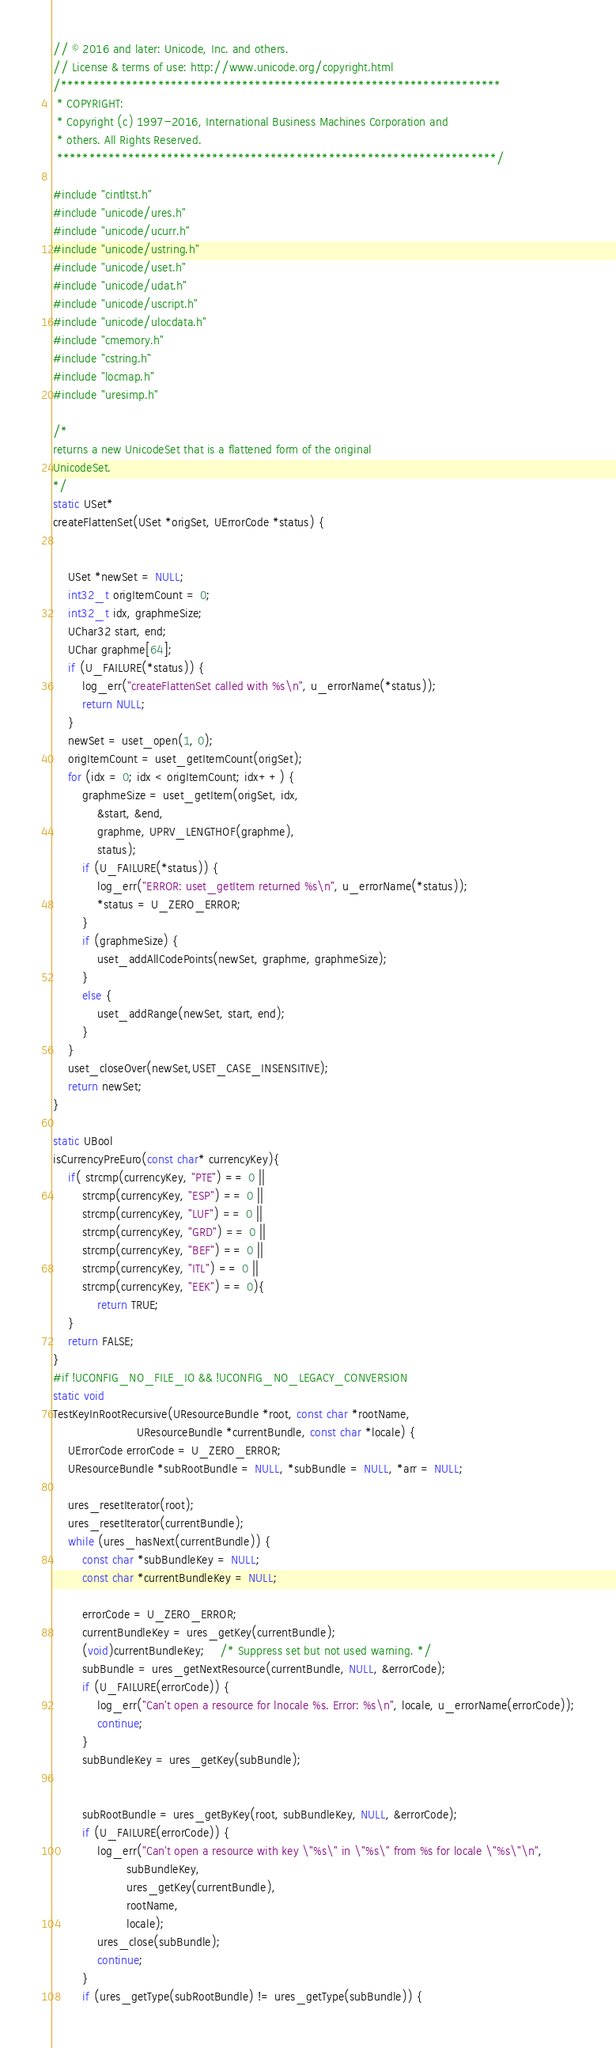Convert code to text. <code><loc_0><loc_0><loc_500><loc_500><_C_>// © 2016 and later: Unicode, Inc. and others.
// License & terms of use: http://www.unicode.org/copyright.html
/********************************************************************
 * COPYRIGHT:
 * Copyright (c) 1997-2016, International Business Machines Corporation and
 * others. All Rights Reserved.
 ********************************************************************/

#include "cintltst.h"
#include "unicode/ures.h"
#include "unicode/ucurr.h"
#include "unicode/ustring.h"
#include "unicode/uset.h"
#include "unicode/udat.h"
#include "unicode/uscript.h"
#include "unicode/ulocdata.h"
#include "cmemory.h"
#include "cstring.h"
#include "locmap.h"
#include "uresimp.h"

/*
returns a new UnicodeSet that is a flattened form of the original
UnicodeSet.
*/
static USet*
createFlattenSet(USet *origSet, UErrorCode *status) {


    USet *newSet = NULL;
    int32_t origItemCount = 0;
    int32_t idx, graphmeSize;
    UChar32 start, end;
    UChar graphme[64];
    if (U_FAILURE(*status)) {
        log_err("createFlattenSet called with %s\n", u_errorName(*status));
        return NULL;
    }
    newSet = uset_open(1, 0);
    origItemCount = uset_getItemCount(origSet);
    for (idx = 0; idx < origItemCount; idx++) {
        graphmeSize = uset_getItem(origSet, idx,
            &start, &end,
            graphme, UPRV_LENGTHOF(graphme),
            status);
        if (U_FAILURE(*status)) {
            log_err("ERROR: uset_getItem returned %s\n", u_errorName(*status));
            *status = U_ZERO_ERROR;
        }
        if (graphmeSize) {
            uset_addAllCodePoints(newSet, graphme, graphmeSize);
        }
        else {
            uset_addRange(newSet, start, end);
        }
    }
    uset_closeOver(newSet,USET_CASE_INSENSITIVE);
    return newSet;
}

static UBool
isCurrencyPreEuro(const char* currencyKey){
    if( strcmp(currencyKey, "PTE") == 0 ||
        strcmp(currencyKey, "ESP") == 0 ||
        strcmp(currencyKey, "LUF") == 0 ||
        strcmp(currencyKey, "GRD") == 0 ||
        strcmp(currencyKey, "BEF") == 0 ||
        strcmp(currencyKey, "ITL") == 0 ||
        strcmp(currencyKey, "EEK") == 0){
            return TRUE;
    }
    return FALSE;
}
#if !UCONFIG_NO_FILE_IO && !UCONFIG_NO_LEGACY_CONVERSION
static void
TestKeyInRootRecursive(UResourceBundle *root, const char *rootName,
                       UResourceBundle *currentBundle, const char *locale) {
    UErrorCode errorCode = U_ZERO_ERROR;
    UResourceBundle *subRootBundle = NULL, *subBundle = NULL, *arr = NULL;

    ures_resetIterator(root);
    ures_resetIterator(currentBundle);
    while (ures_hasNext(currentBundle)) {
        const char *subBundleKey = NULL;
        const char *currentBundleKey = NULL;

        errorCode = U_ZERO_ERROR;
        currentBundleKey = ures_getKey(currentBundle);
        (void)currentBundleKey;    /* Suppress set but not used warning. */
        subBundle = ures_getNextResource(currentBundle, NULL, &errorCode);
        if (U_FAILURE(errorCode)) {
            log_err("Can't open a resource for lnocale %s. Error: %s\n", locale, u_errorName(errorCode));
            continue;
        }
        subBundleKey = ures_getKey(subBundle);


        subRootBundle = ures_getByKey(root, subBundleKey, NULL, &errorCode);
        if (U_FAILURE(errorCode)) {
            log_err("Can't open a resource with key \"%s\" in \"%s\" from %s for locale \"%s\"\n",
                    subBundleKey,
                    ures_getKey(currentBundle),
                    rootName,
                    locale);
            ures_close(subBundle);
            continue;
        }
        if (ures_getType(subRootBundle) != ures_getType(subBundle)) {</code> 